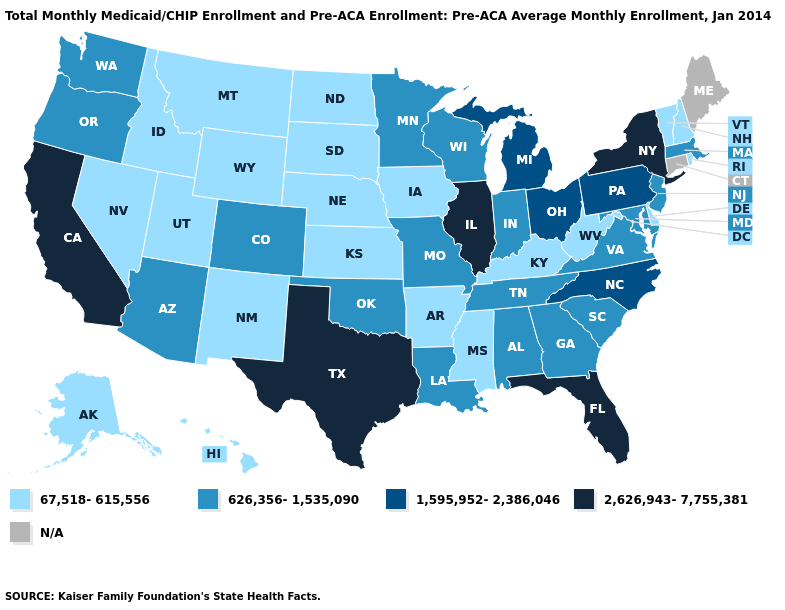Name the states that have a value in the range 67,518-615,556?
Answer briefly. Alaska, Arkansas, Delaware, Hawaii, Idaho, Iowa, Kansas, Kentucky, Mississippi, Montana, Nebraska, Nevada, New Hampshire, New Mexico, North Dakota, Rhode Island, South Dakota, Utah, Vermont, West Virginia, Wyoming. Does Rhode Island have the lowest value in the Northeast?
Write a very short answer. Yes. Among the states that border Michigan , does Indiana have the lowest value?
Be succinct. Yes. Among the states that border Mississippi , does Arkansas have the lowest value?
Answer briefly. Yes. Name the states that have a value in the range 67,518-615,556?
Give a very brief answer. Alaska, Arkansas, Delaware, Hawaii, Idaho, Iowa, Kansas, Kentucky, Mississippi, Montana, Nebraska, Nevada, New Hampshire, New Mexico, North Dakota, Rhode Island, South Dakota, Utah, Vermont, West Virginia, Wyoming. Does New Mexico have the lowest value in the USA?
Give a very brief answer. Yes. What is the value of Alaska?
Be succinct. 67,518-615,556. Which states have the highest value in the USA?
Be succinct. California, Florida, Illinois, New York, Texas. Does New York have the lowest value in the Northeast?
Give a very brief answer. No. Name the states that have a value in the range N/A?
Short answer required. Connecticut, Maine. What is the value of Arizona?
Keep it brief. 626,356-1,535,090. What is the value of Texas?
Answer briefly. 2,626,943-7,755,381. Does Missouri have the lowest value in the MidWest?
Be succinct. No. Among the states that border Kentucky , which have the highest value?
Quick response, please. Illinois. Which states have the lowest value in the South?
Keep it brief. Arkansas, Delaware, Kentucky, Mississippi, West Virginia. 